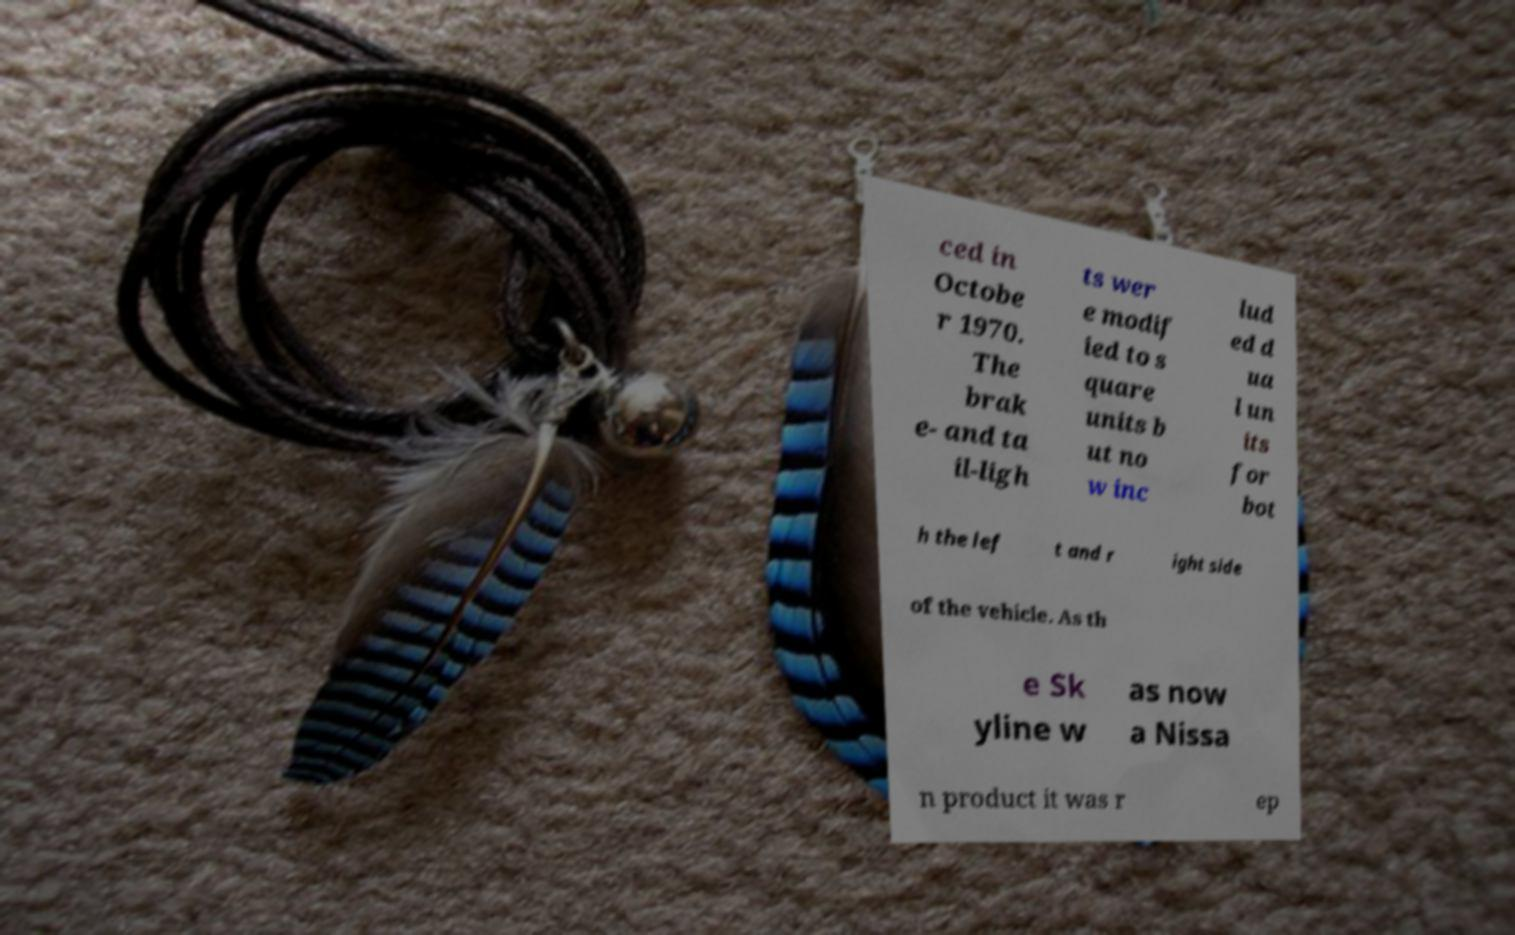There's text embedded in this image that I need extracted. Can you transcribe it verbatim? ced in Octobe r 1970. The brak e- and ta il-ligh ts wer e modif ied to s quare units b ut no w inc lud ed d ua l un its for bot h the lef t and r ight side of the vehicle. As th e Sk yline w as now a Nissa n product it was r ep 